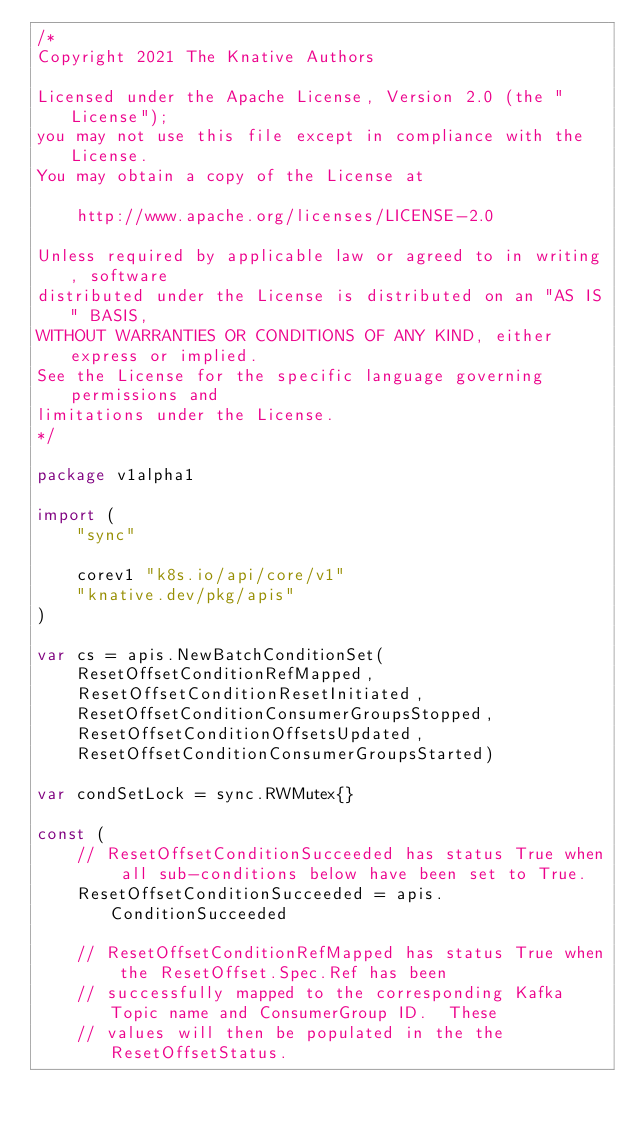Convert code to text. <code><loc_0><loc_0><loc_500><loc_500><_Go_>/*
Copyright 2021 The Knative Authors

Licensed under the Apache License, Version 2.0 (the "License");
you may not use this file except in compliance with the License.
You may obtain a copy of the License at

    http://www.apache.org/licenses/LICENSE-2.0

Unless required by applicable law or agreed to in writing, software
distributed under the License is distributed on an "AS IS" BASIS,
WITHOUT WARRANTIES OR CONDITIONS OF ANY KIND, either express or implied.
See the License for the specific language governing permissions and
limitations under the License.
*/

package v1alpha1

import (
	"sync"

	corev1 "k8s.io/api/core/v1"
	"knative.dev/pkg/apis"
)

var cs = apis.NewBatchConditionSet(
	ResetOffsetConditionRefMapped,
	ResetOffsetConditionResetInitiated,
	ResetOffsetConditionConsumerGroupsStopped,
	ResetOffsetConditionOffsetsUpdated,
	ResetOffsetConditionConsumerGroupsStarted)

var condSetLock = sync.RWMutex{}

const (
	// ResetOffsetConditionSucceeded has status True when all sub-conditions below have been set to True.
	ResetOffsetConditionSucceeded = apis.ConditionSucceeded

	// ResetOffsetConditionRefMapped has status True when the ResetOffset.Spec.Ref has been
	// successfully mapped to the corresponding Kafka Topic name and ConsumerGroup ID.  These
	// values will then be populated in the the ResetOffsetStatus.</code> 